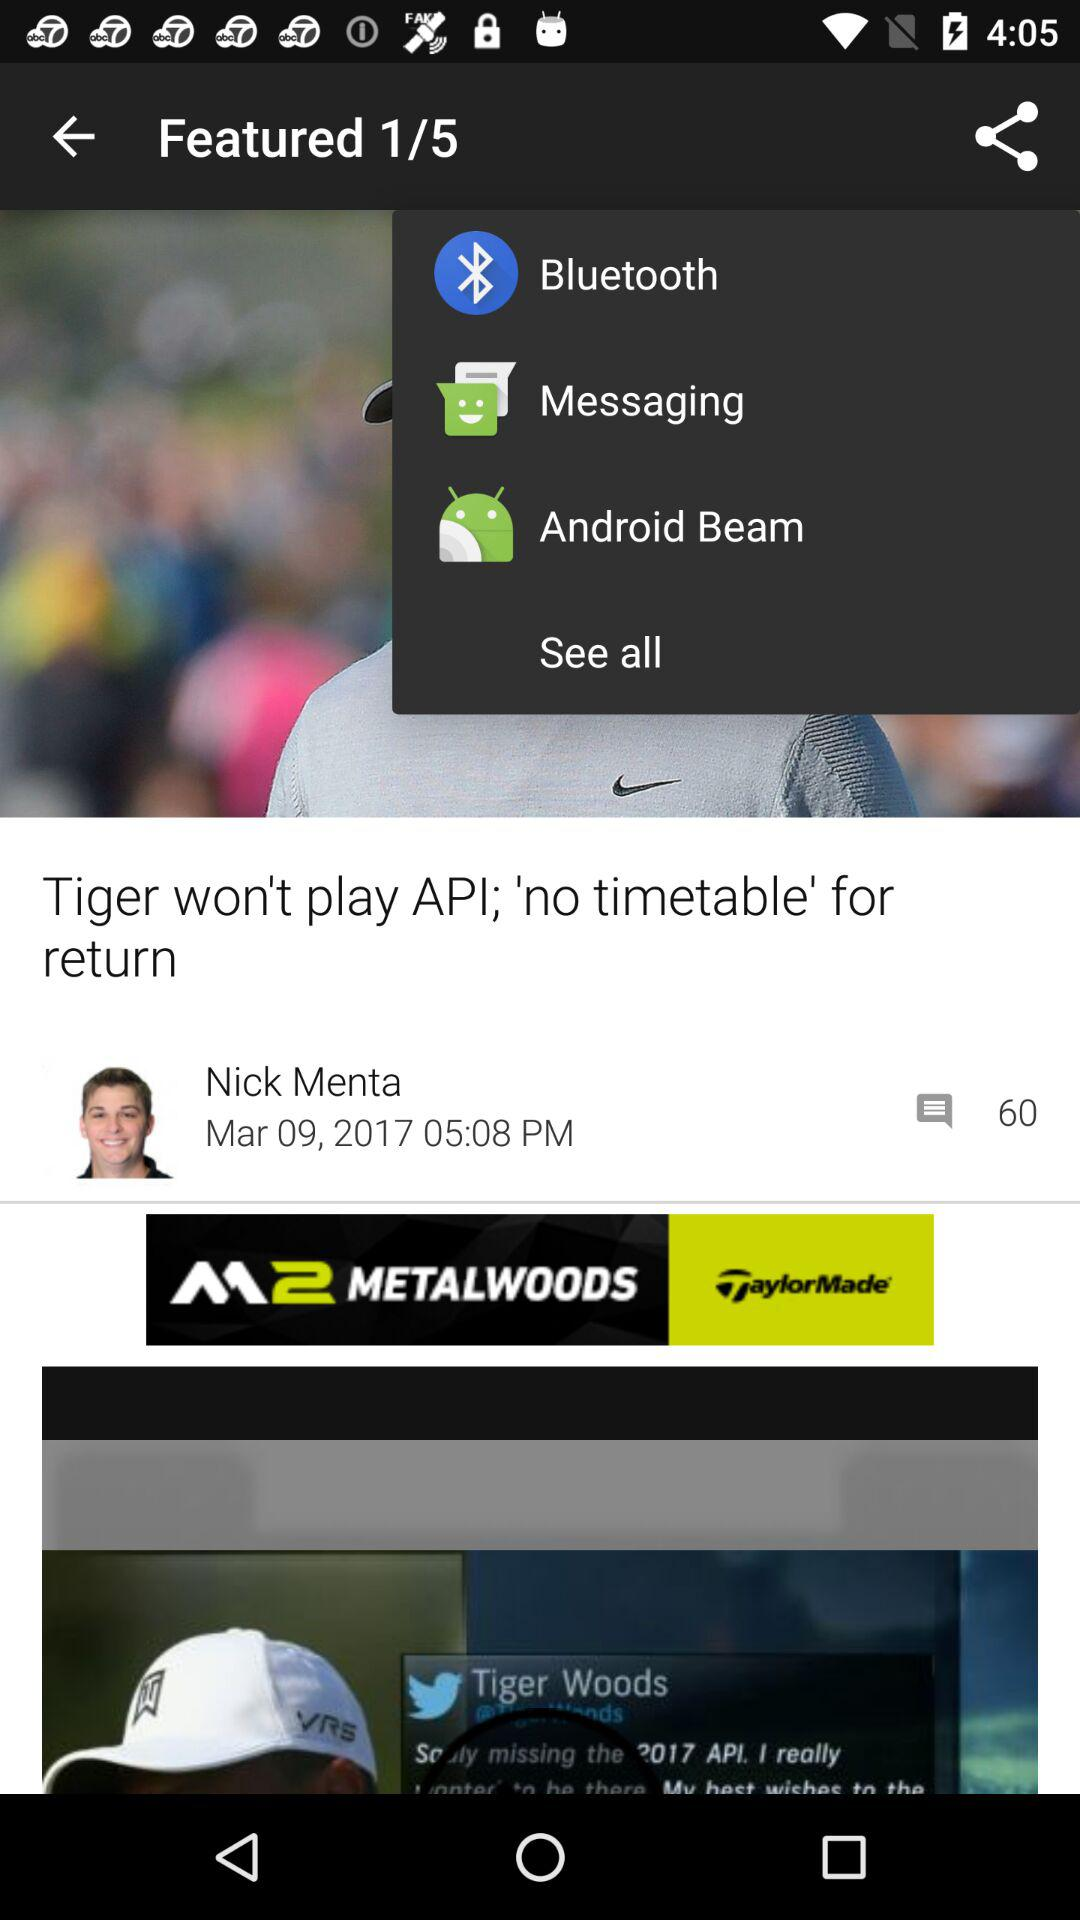What are the sharing options? The sharing options are "Bluetooth", "Messaging" and "Android Beam". 